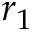<formula> <loc_0><loc_0><loc_500><loc_500>r _ { 1 }</formula> 